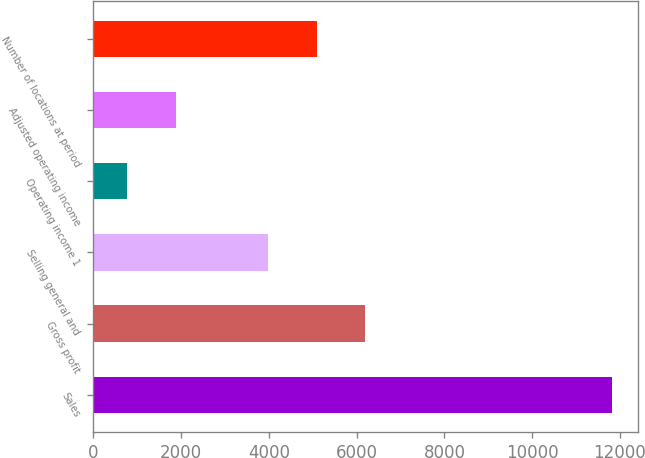<chart> <loc_0><loc_0><loc_500><loc_500><bar_chart><fcel>Sales<fcel>Gross profit<fcel>Selling general and<fcel>Operating income 1<fcel>Adjusted operating income<fcel>Number of locations at period<nl><fcel>11813<fcel>6190.4<fcel>3982<fcel>771<fcel>1875.2<fcel>5086.2<nl></chart> 